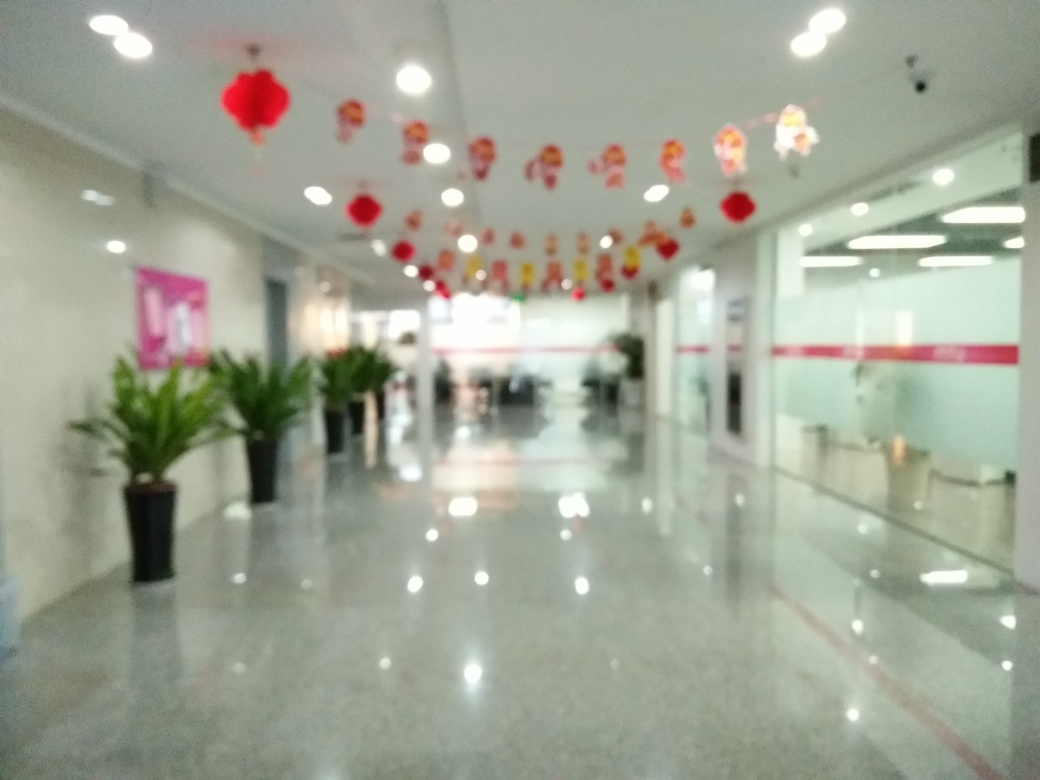Could you describe the atmosphere or mood conveyed by this image? The image suggests a festive or celebratory atmosphere, likely due to the red lanterns and decorative hangings that adorn the ceiling of the corridor. These decorations are often associated with joyous occasions and could indicate a special event or cultural celebration taking place at this location. The use of red is particularly notable as it is a color that traditionally symbolizes happiness and good fortune in many cultures. Despite the blurriness, the reflections on the shiny floor and the neat arrangement of potted plants contribute to a sense of order and preparation for an event. 